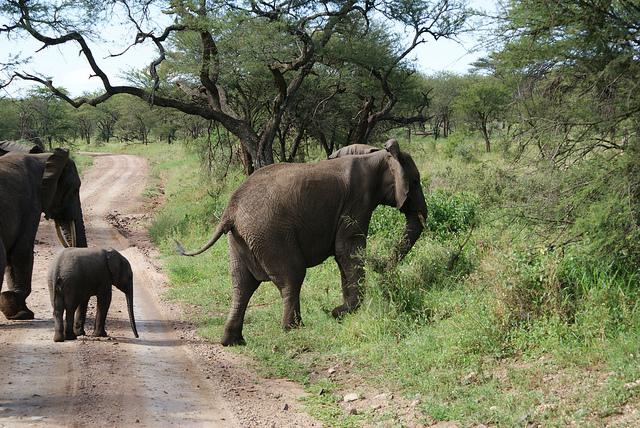How many elephants are standing right on the dirt road to the left?

Choices:
A) five
B) four
C) three
D) two two 